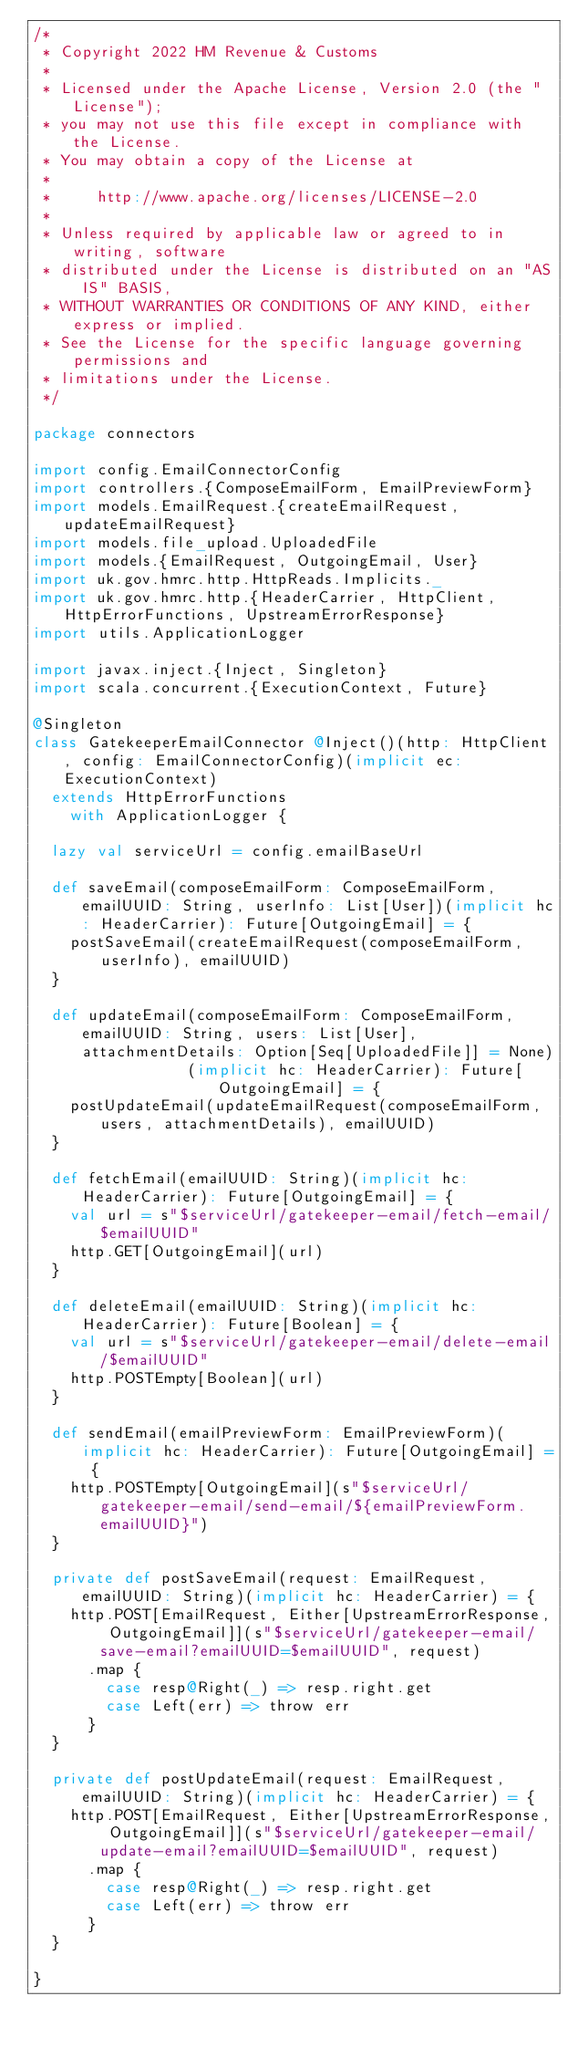Convert code to text. <code><loc_0><loc_0><loc_500><loc_500><_Scala_>/*
 * Copyright 2022 HM Revenue & Customs
 *
 * Licensed under the Apache License, Version 2.0 (the "License");
 * you may not use this file except in compliance with the License.
 * You may obtain a copy of the License at
 *
 *     http://www.apache.org/licenses/LICENSE-2.0
 *
 * Unless required by applicable law or agreed to in writing, software
 * distributed under the License is distributed on an "AS IS" BASIS,
 * WITHOUT WARRANTIES OR CONDITIONS OF ANY KIND, either express or implied.
 * See the License for the specific language governing permissions and
 * limitations under the License.
 */

package connectors

import config.EmailConnectorConfig
import controllers.{ComposeEmailForm, EmailPreviewForm}
import models.EmailRequest.{createEmailRequest, updateEmailRequest}
import models.file_upload.UploadedFile
import models.{EmailRequest, OutgoingEmail, User}
import uk.gov.hmrc.http.HttpReads.Implicits._
import uk.gov.hmrc.http.{HeaderCarrier, HttpClient, HttpErrorFunctions, UpstreamErrorResponse}
import utils.ApplicationLogger

import javax.inject.{Inject, Singleton}
import scala.concurrent.{ExecutionContext, Future}

@Singleton
class GatekeeperEmailConnector @Inject()(http: HttpClient, config: EmailConnectorConfig)(implicit ec: ExecutionContext)
  extends HttpErrorFunctions
    with ApplicationLogger {

  lazy val serviceUrl = config.emailBaseUrl

  def saveEmail(composeEmailForm: ComposeEmailForm, emailUUID: String, userInfo: List[User])(implicit hc: HeaderCarrier): Future[OutgoingEmail] = {
    postSaveEmail(createEmailRequest(composeEmailForm, userInfo), emailUUID)
  }

  def updateEmail(composeEmailForm: ComposeEmailForm, emailUUID: String, users: List[User], attachmentDetails: Option[Seq[UploadedFile]] = None)
                 (implicit hc: HeaderCarrier): Future[OutgoingEmail] = {
    postUpdateEmail(updateEmailRequest(composeEmailForm, users, attachmentDetails), emailUUID)
  }

  def fetchEmail(emailUUID: String)(implicit hc: HeaderCarrier): Future[OutgoingEmail] = {
    val url = s"$serviceUrl/gatekeeper-email/fetch-email/$emailUUID"
    http.GET[OutgoingEmail](url)
  }

  def deleteEmail(emailUUID: String)(implicit hc: HeaderCarrier): Future[Boolean] = {
    val url = s"$serviceUrl/gatekeeper-email/delete-email/$emailUUID"
    http.POSTEmpty[Boolean](url)
  }

  def sendEmail(emailPreviewForm: EmailPreviewForm)(implicit hc: HeaderCarrier): Future[OutgoingEmail] = {
    http.POSTEmpty[OutgoingEmail](s"$serviceUrl/gatekeeper-email/send-email/${emailPreviewForm.emailUUID}")
  }

  private def postSaveEmail(request: EmailRequest, emailUUID: String)(implicit hc: HeaderCarrier) = {
    http.POST[EmailRequest, Either[UpstreamErrorResponse, OutgoingEmail]](s"$serviceUrl/gatekeeper-email/save-email?emailUUID=$emailUUID", request)
      .map {
        case resp@Right(_) => resp.right.get
        case Left(err) => throw err
      }
  }

  private def postUpdateEmail(request: EmailRequest, emailUUID: String)(implicit hc: HeaderCarrier) = {
    http.POST[EmailRequest, Either[UpstreamErrorResponse, OutgoingEmail]](s"$serviceUrl/gatekeeper-email/update-email?emailUUID=$emailUUID", request)
      .map {
        case resp@Right(_) => resp.right.get
        case Left(err) => throw err
      }
  }

}</code> 